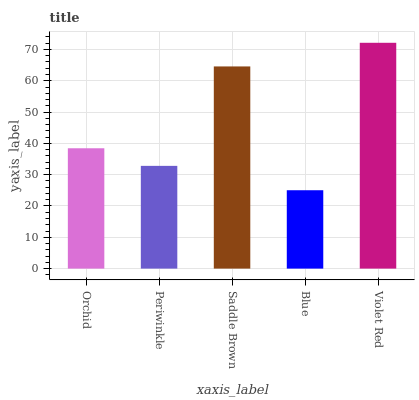Is Blue the minimum?
Answer yes or no. Yes. Is Violet Red the maximum?
Answer yes or no. Yes. Is Periwinkle the minimum?
Answer yes or no. No. Is Periwinkle the maximum?
Answer yes or no. No. Is Orchid greater than Periwinkle?
Answer yes or no. Yes. Is Periwinkle less than Orchid?
Answer yes or no. Yes. Is Periwinkle greater than Orchid?
Answer yes or no. No. Is Orchid less than Periwinkle?
Answer yes or no. No. Is Orchid the high median?
Answer yes or no. Yes. Is Orchid the low median?
Answer yes or no. Yes. Is Periwinkle the high median?
Answer yes or no. No. Is Saddle Brown the low median?
Answer yes or no. No. 